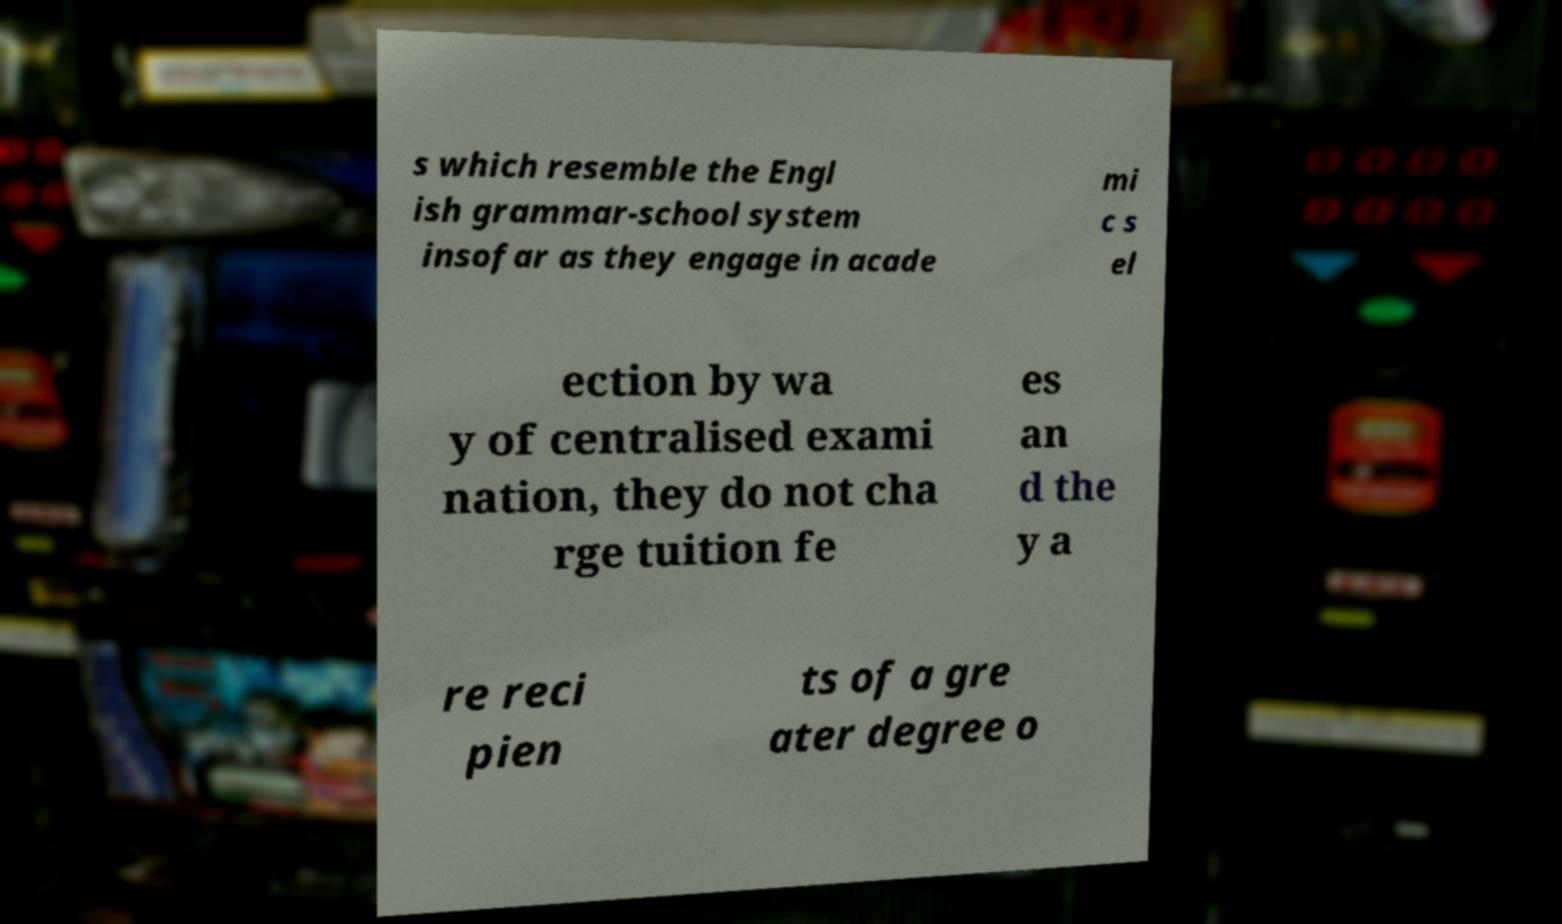Can you read and provide the text displayed in the image?This photo seems to have some interesting text. Can you extract and type it out for me? s which resemble the Engl ish grammar-school system insofar as they engage in acade mi c s el ection by wa y of centralised exami nation, they do not cha rge tuition fe es an d the y a re reci pien ts of a gre ater degree o 